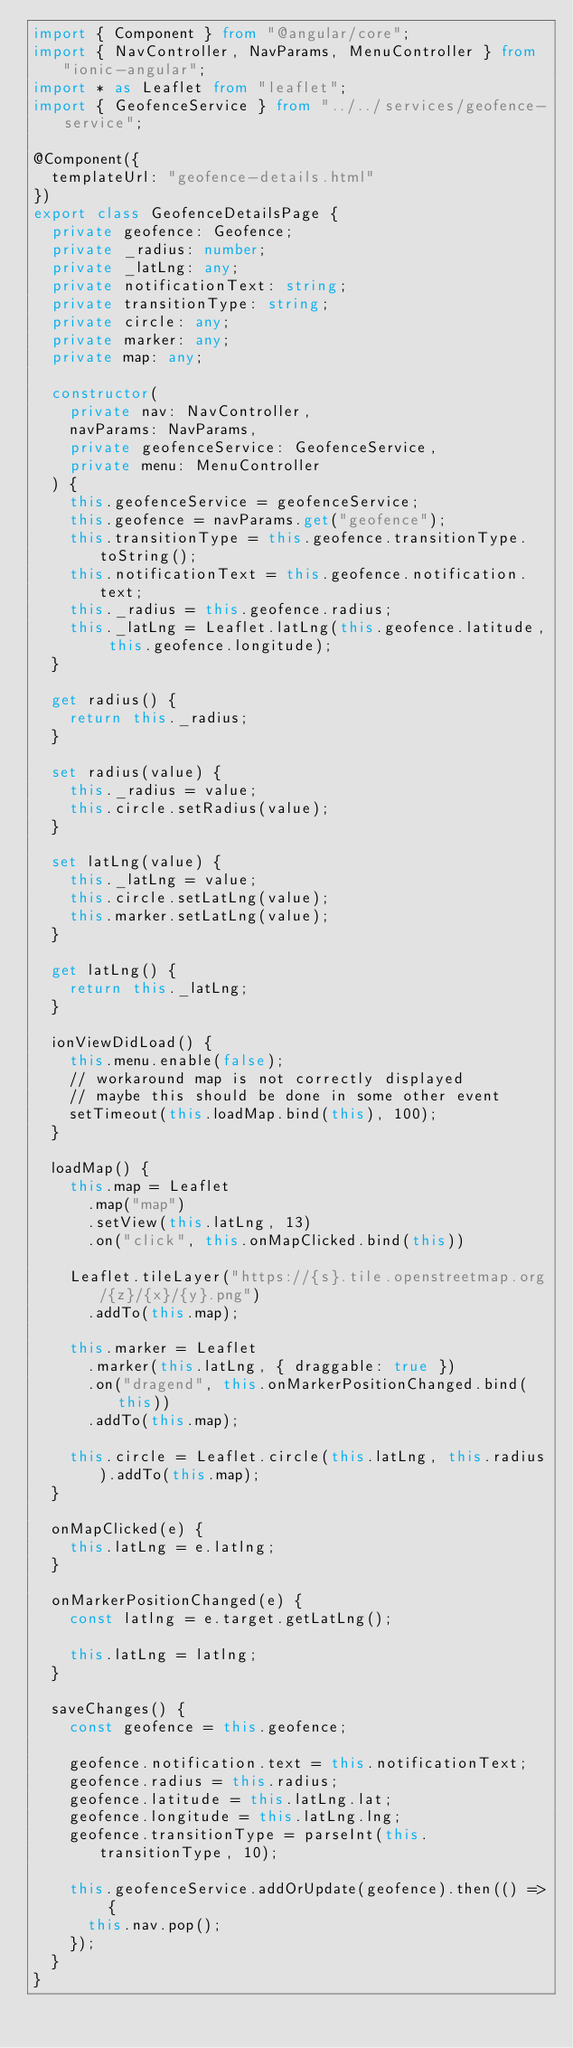Convert code to text. <code><loc_0><loc_0><loc_500><loc_500><_TypeScript_>import { Component } from "@angular/core";
import { NavController, NavParams, MenuController } from "ionic-angular";
import * as Leaflet from "leaflet";
import { GeofenceService } from "../../services/geofence-service";

@Component({
  templateUrl: "geofence-details.html"
})
export class GeofenceDetailsPage {
  private geofence: Geofence;
  private _radius: number;
  private _latLng: any;
  private notificationText: string;
  private transitionType: string;
  private circle: any;
  private marker: any;
  private map: any;

  constructor(
    private nav: NavController,
    navParams: NavParams,
    private geofenceService: GeofenceService,
    private menu: MenuController
  ) {
    this.geofenceService = geofenceService;
    this.geofence = navParams.get("geofence");
    this.transitionType = this.geofence.transitionType.toString();
    this.notificationText = this.geofence.notification.text;
    this._radius = this.geofence.radius;
    this._latLng = Leaflet.latLng(this.geofence.latitude, this.geofence.longitude);
  }

  get radius() {
    return this._radius;
  }

  set radius(value) {
    this._radius = value;
    this.circle.setRadius(value);
  }

  set latLng(value) {
    this._latLng = value;
    this.circle.setLatLng(value);
    this.marker.setLatLng(value);
  }

  get latLng() {
    return this._latLng;
  }

  ionViewDidLoad() {
    this.menu.enable(false);
    // workaround map is not correctly displayed
    // maybe this should be done in some other event
    setTimeout(this.loadMap.bind(this), 100);
  }

  loadMap() {
    this.map = Leaflet
      .map("map")
      .setView(this.latLng, 13)
      .on("click", this.onMapClicked.bind(this))

    Leaflet.tileLayer("https://{s}.tile.openstreetmap.org/{z}/{x}/{y}.png")
      .addTo(this.map);

    this.marker = Leaflet
      .marker(this.latLng, { draggable: true })
      .on("dragend", this.onMarkerPositionChanged.bind(this))
      .addTo(this.map);

    this.circle = Leaflet.circle(this.latLng, this.radius).addTo(this.map);
  }

  onMapClicked(e) {
    this.latLng = e.latlng;
  }

  onMarkerPositionChanged(e) {
    const latlng = e.target.getLatLng();

    this.latLng = latlng;
  }

  saveChanges() {
    const geofence = this.geofence;

    geofence.notification.text = this.notificationText;
    geofence.radius = this.radius;
    geofence.latitude = this.latLng.lat;
    geofence.longitude = this.latLng.lng;
    geofence.transitionType = parseInt(this.transitionType, 10);

    this.geofenceService.addOrUpdate(geofence).then(() => {
      this.nav.pop();
    });
  }
}
</code> 